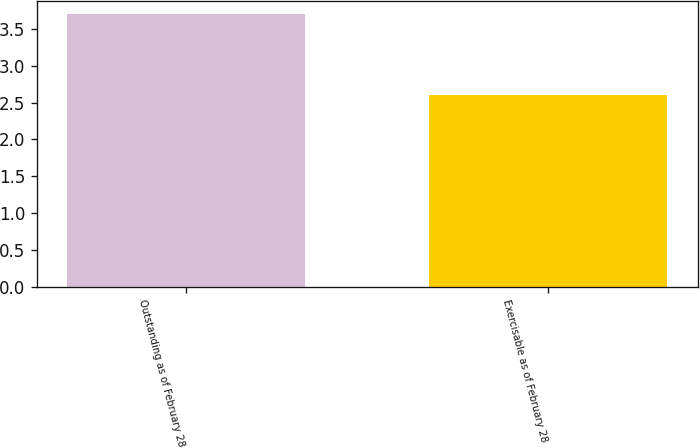Convert chart to OTSL. <chart><loc_0><loc_0><loc_500><loc_500><bar_chart><fcel>Outstanding as of February 28<fcel>Exercisable as of February 28<nl><fcel>3.7<fcel>2.6<nl></chart> 